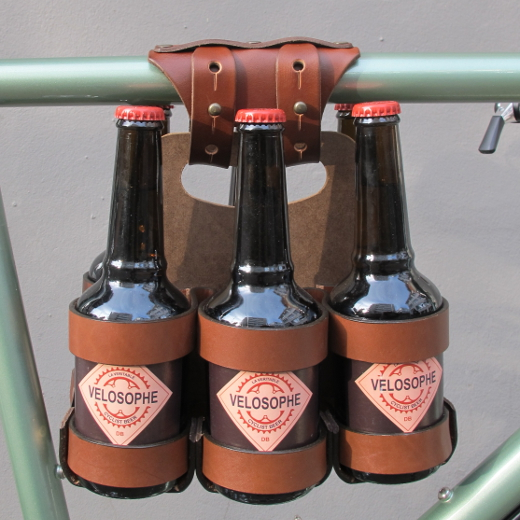Let's get imaginative. If these bottles could talk, what might they say about their journey? If these bottles could talk, they might share tales of adventure from picnicking in sprawling parks to watching sunsets by the lake. They'd recount the laughter of friends during impromptu gatherings, the clinking sounds they make riding through cobblestone streets, and the refreshing moments under a shade on a hot day. Each scratch on their label and each bubble in their liquid would narrate stories of joy, companionship, and discovery. 